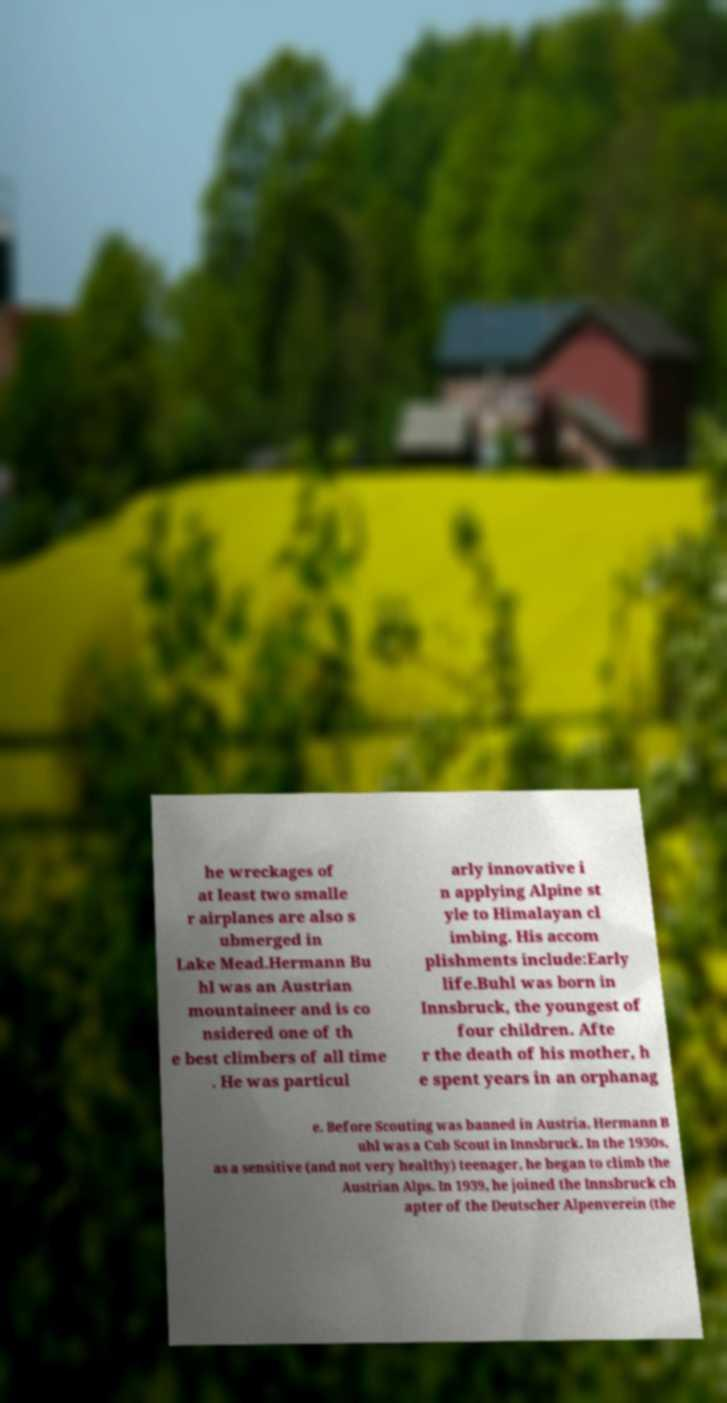Can you accurately transcribe the text from the provided image for me? he wreckages of at least two smalle r airplanes are also s ubmerged in Lake Mead.Hermann Bu hl was an Austrian mountaineer and is co nsidered one of th e best climbers of all time . He was particul arly innovative i n applying Alpine st yle to Himalayan cl imbing. His accom plishments include:Early life.Buhl was born in Innsbruck, the youngest of four children. Afte r the death of his mother, h e spent years in an orphanag e. Before Scouting was banned in Austria, Hermann B uhl was a Cub Scout in Innsbruck. In the 1930s, as a sensitive (and not very healthy) teenager, he began to climb the Austrian Alps. In 1939, he joined the Innsbruck ch apter of the Deutscher Alpenverein (the 